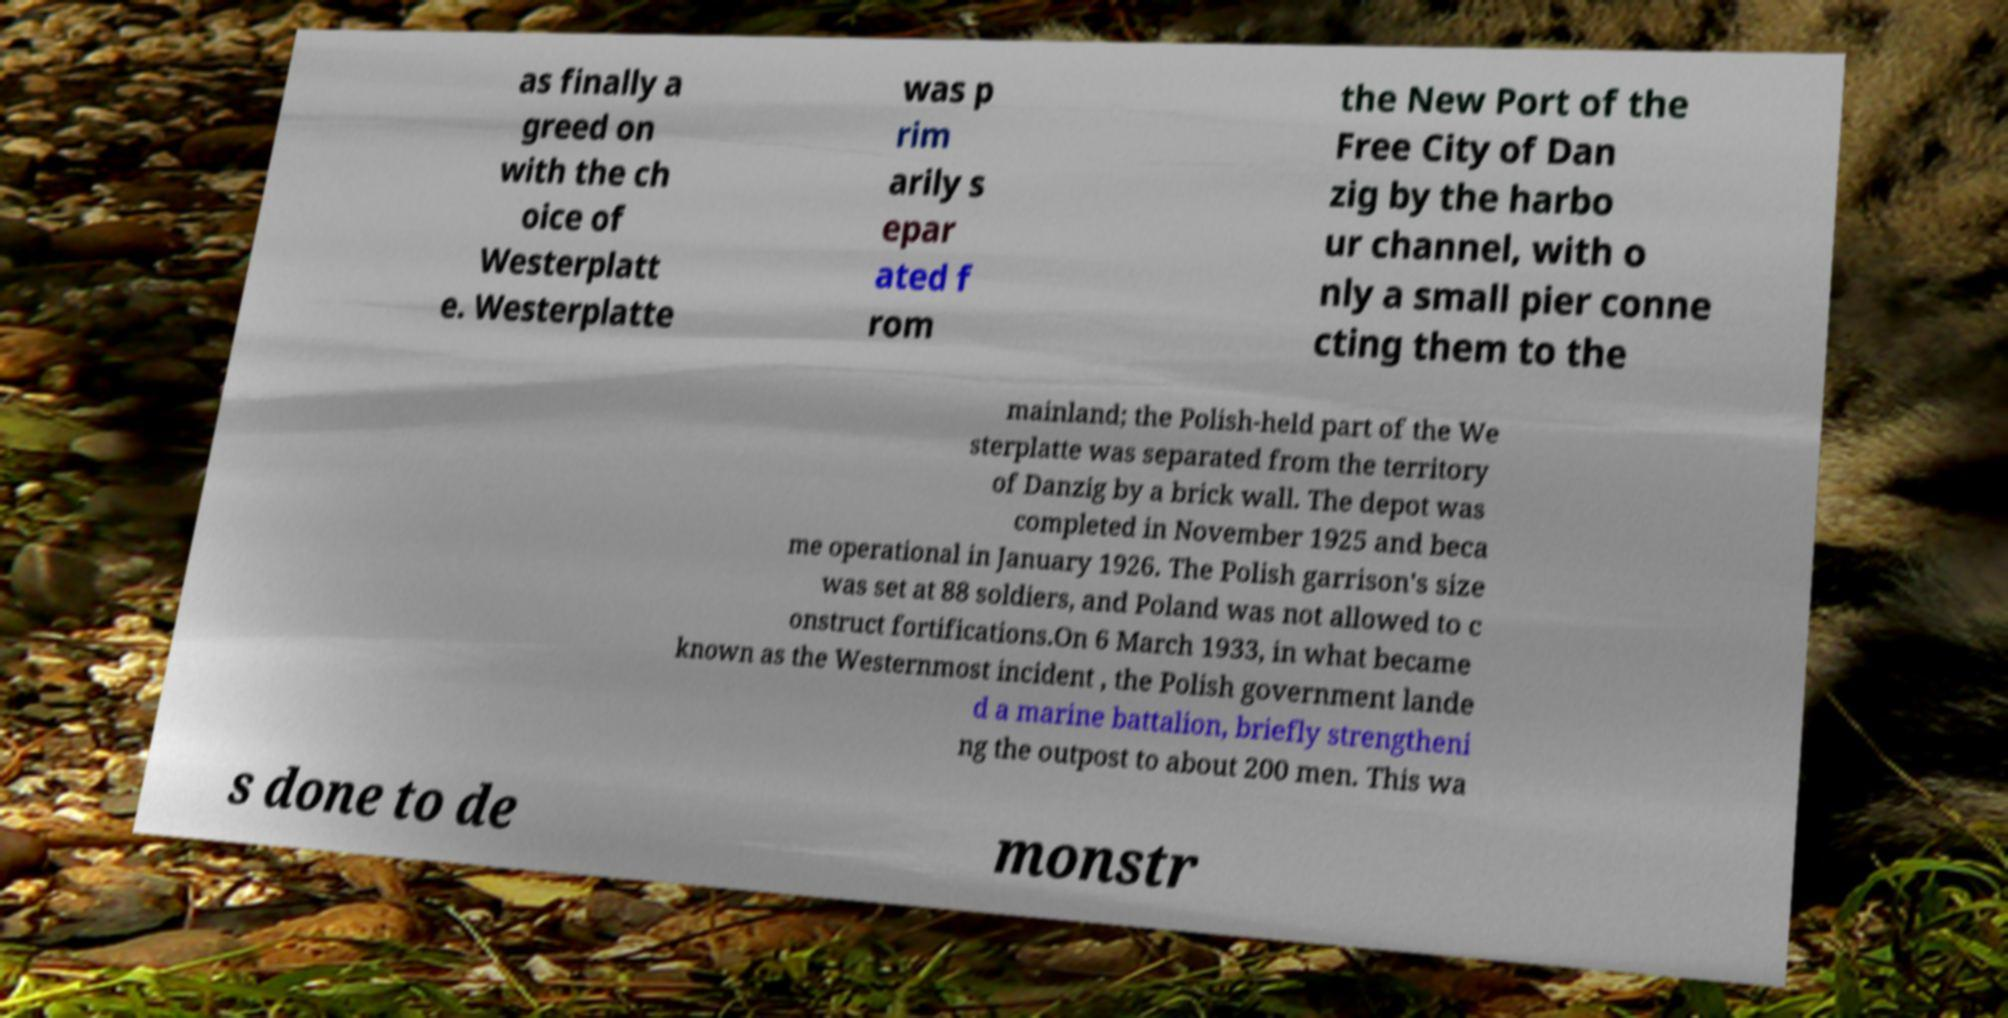Could you assist in decoding the text presented in this image and type it out clearly? as finally a greed on with the ch oice of Westerplatt e. Westerplatte was p rim arily s epar ated f rom the New Port of the Free City of Dan zig by the harbo ur channel, with o nly a small pier conne cting them to the mainland; the Polish-held part of the We sterplatte was separated from the territory of Danzig by a brick wall. The depot was completed in November 1925 and beca me operational in January 1926. The Polish garrison's size was set at 88 soldiers, and Poland was not allowed to c onstruct fortifications.On 6 March 1933, in what became known as the Westernmost incident , the Polish government lande d a marine battalion, briefly strengtheni ng the outpost to about 200 men. This wa s done to de monstr 